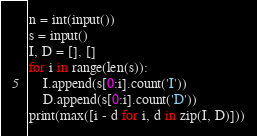Convert code to text. <code><loc_0><loc_0><loc_500><loc_500><_Python_>n = int(input())
s = input()
I, D = [], []
for i in range(len(s)):
    I.append(s[0:i].count('I'))
    D.append(s[0:i].count('D'))
print(max([i - d for i, d in zip(I, D)]))
</code> 